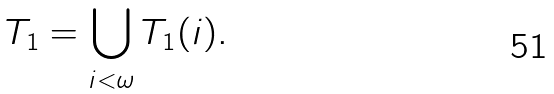Convert formula to latex. <formula><loc_0><loc_0><loc_500><loc_500>T _ { 1 } = \bigcup _ { i < \omega } T _ { 1 } ( i ) .</formula> 